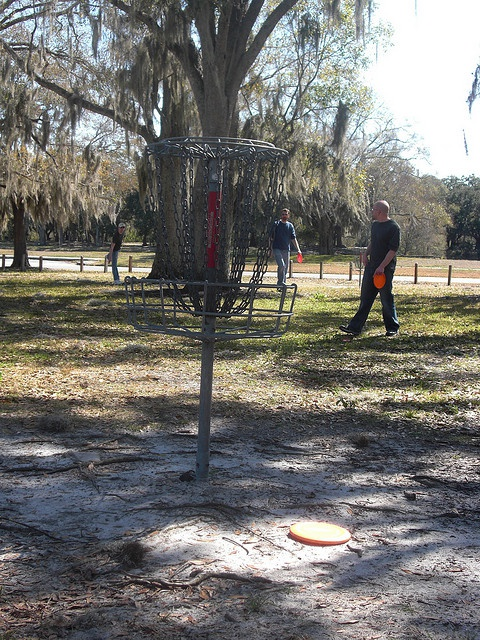Describe the objects in this image and their specific colors. I can see people in lavender, black, gray, brown, and maroon tones, people in lavender, black, gray, and darkblue tones, frisbee in lavender, ivory, brown, khaki, and salmon tones, people in lavender, black, gray, and darkblue tones, and frisbee in lavender, brown, maroon, and black tones in this image. 